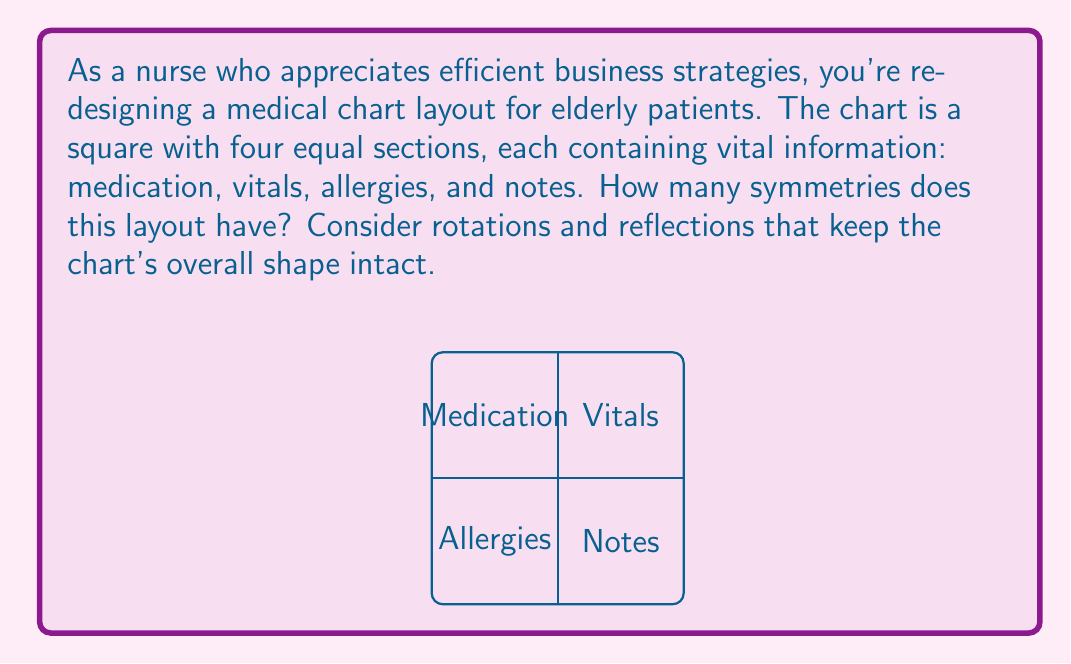Solve this math problem. To find the symmetry group of this medical chart layout, we need to consider all the transformations that leave the square shape unchanged while potentially rearranging the four sections. Let's approach this step-by-step:

1) Rotational symmetries:
   - 0° rotation (identity)
   - 90° clockwise rotation
   - 180° rotation
   - 270° clockwise rotation (or 90° counterclockwise)

2) Reflection symmetries:
   - Reflection across the vertical axis
   - Reflection across the horizontal axis
   - Reflection across the diagonal from top-left to bottom-right
   - Reflection across the diagonal from top-right to bottom-left

In total, we have 8 symmetries. These symmetries form a group under composition, known as the dihedral group of order 8, denoted as $D_4$ or $D_8$ (depending on the notation system).

The group structure can be represented as:
$$D_4 = \{e, r, r^2, r^3, f, fr, fr^2, fr^3\}$$

Where:
- $e$ is the identity transformation
- $r$ represents a 90° clockwise rotation
- $f$ represents a reflection (usually taken as the reflection across the vertical axis)

This group is isomorphic to the symmetry group of a square, which is why it applies perfectly to our square medical chart layout.

The order of this group is 8, which matches our count of distinct symmetries.
Answer: $D_4$ (or $D_8$), order 8 